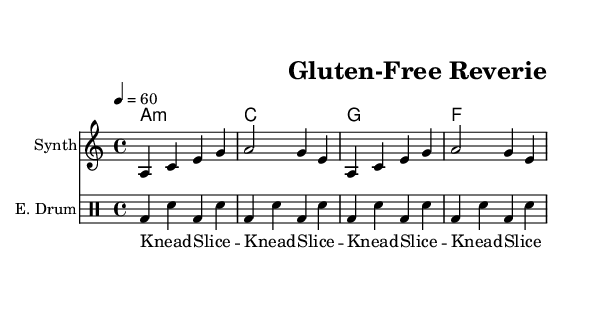What is the key signature of this music? The key signature is indicated by the 'key' command in the global section of the code, which shows 'a minor'. It reflects that there are no sharps or flats in the music.
Answer: A minor What is the time signature of this music? The time signature is defined in the global section under the 'time' command. It is stated as '4/4', meaning there are four beats in each measure, and the quarter note gets one beat.
Answer: 4/4 What is the tempo of the piece? The tempo is defined in the global section with '4 = 60', which indicates a tempo marking of 60 beats per minute, suggesting a slow, steady pace for the music.
Answer: 60 What type of sounds are incorporated in the 'breadSounds' lyrics? The lyrics in the 'breadSounds' section explicitly include the activities of kneading and slicing, represented by the words "Knead" and "Slice". The repeated sequence emphasizes these actions.
Answer: Knead, Slice Which instruments are featured in this score? The score includes three distinct parts: a synthesizer labeled 'Synth', an electronic drum set labeled 'E. Drum', and a section for the chord names, which serves accompaniment.
Answer: Synth, E. Drum What is the emotional tone conveyed by the chord progression? The chord progression uses a mix of minor ('a minor'), major ('c major'), and lower chords ('g major' and 'f major'), creating a reflective, perhaps melancholic emotional quality typical in ambient electronica.
Answer: Reflective 